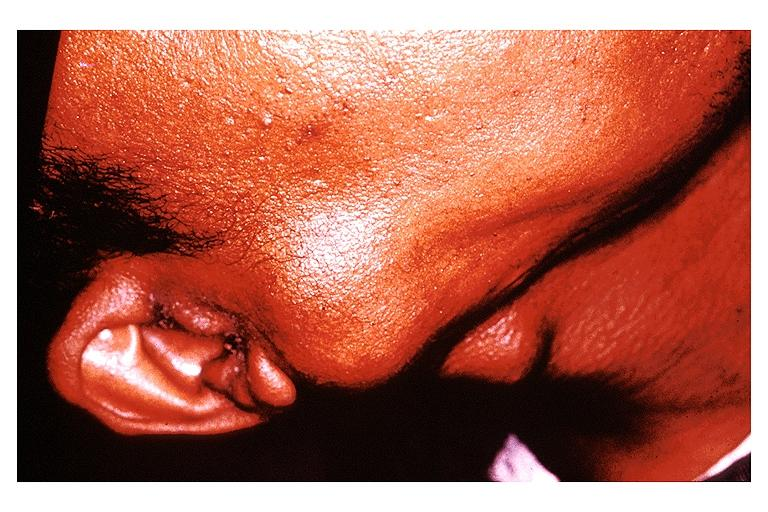s oral present?
Answer the question using a single word or phrase. Yes 